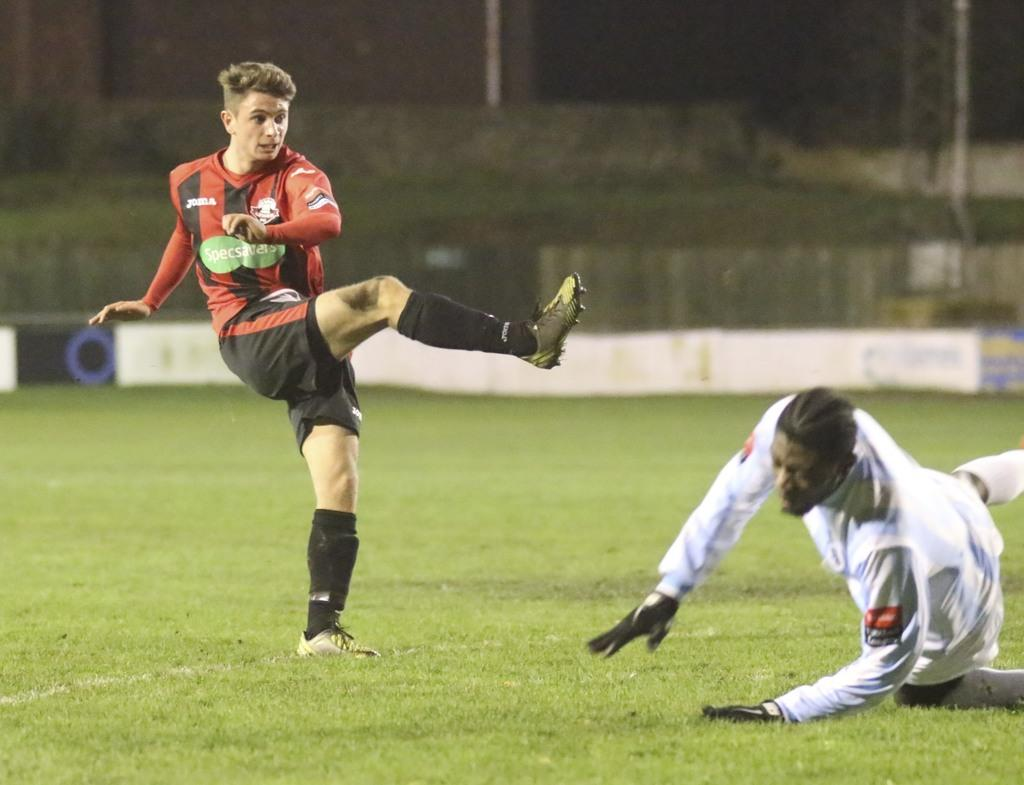How many people are in the image? There are two men in the image. What is the position of the men in the image? The men are on the ground. What can be seen in the background of the image? There is grass, poles, and a wall in the background of the image. What type of drawer can be seen in the image? There is no drawer present in the image. What kind of vessel is being used by the men in the image? The image does not show any vessels being used by the men. 